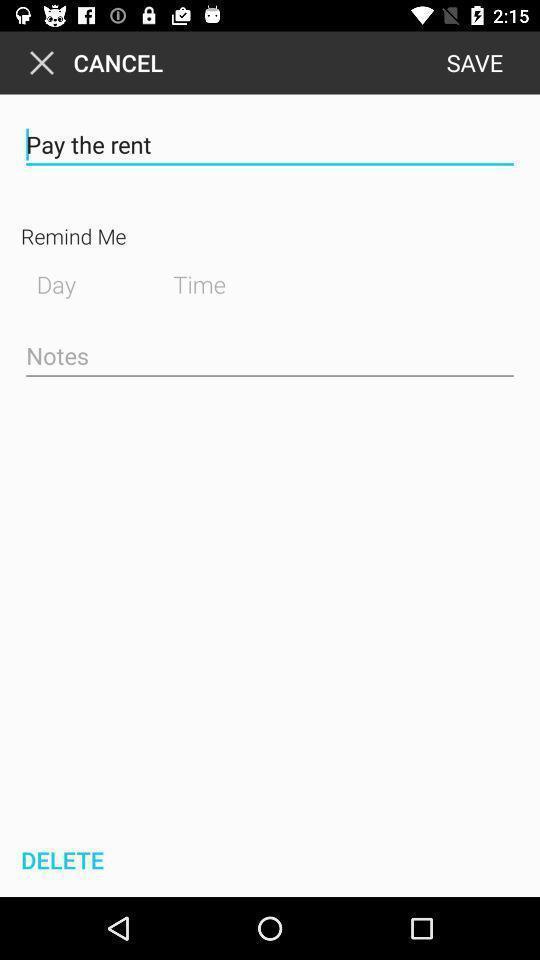What is the overall content of this screenshot? Page showing rent reminder settings. 